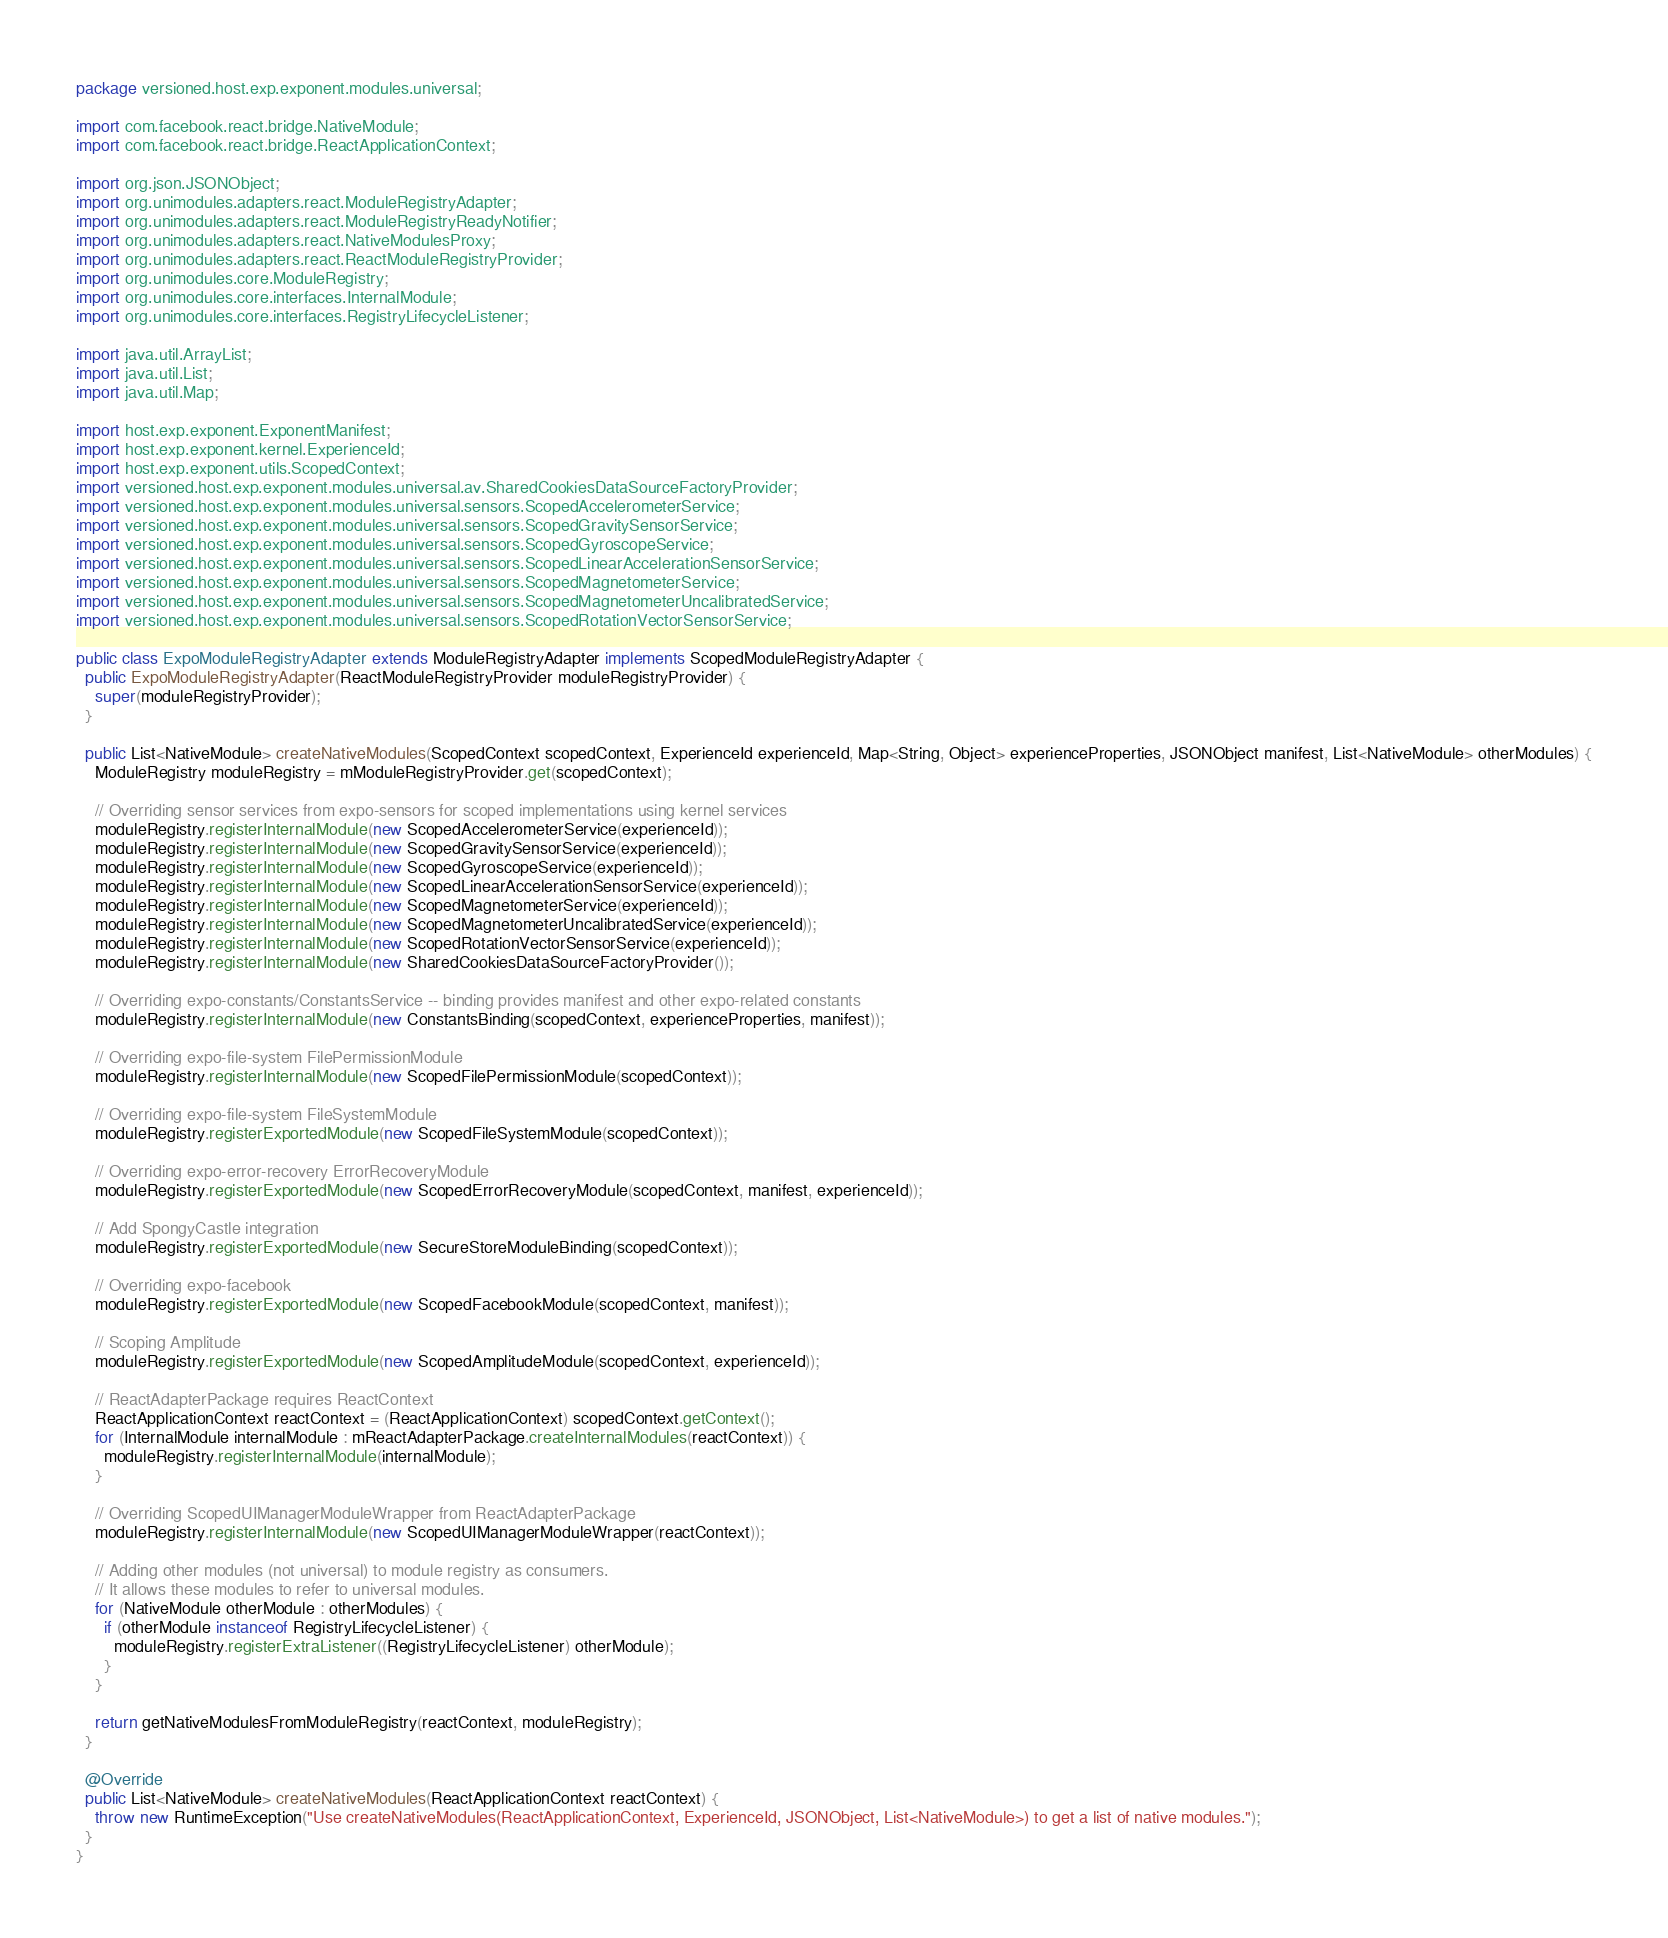<code> <loc_0><loc_0><loc_500><loc_500><_Java_>package versioned.host.exp.exponent.modules.universal;

import com.facebook.react.bridge.NativeModule;
import com.facebook.react.bridge.ReactApplicationContext;

import org.json.JSONObject;
import org.unimodules.adapters.react.ModuleRegistryAdapter;
import org.unimodules.adapters.react.ModuleRegistryReadyNotifier;
import org.unimodules.adapters.react.NativeModulesProxy;
import org.unimodules.adapters.react.ReactModuleRegistryProvider;
import org.unimodules.core.ModuleRegistry;
import org.unimodules.core.interfaces.InternalModule;
import org.unimodules.core.interfaces.RegistryLifecycleListener;

import java.util.ArrayList;
import java.util.List;
import java.util.Map;

import host.exp.exponent.ExponentManifest;
import host.exp.exponent.kernel.ExperienceId;
import host.exp.exponent.utils.ScopedContext;
import versioned.host.exp.exponent.modules.universal.av.SharedCookiesDataSourceFactoryProvider;
import versioned.host.exp.exponent.modules.universal.sensors.ScopedAccelerometerService;
import versioned.host.exp.exponent.modules.universal.sensors.ScopedGravitySensorService;
import versioned.host.exp.exponent.modules.universal.sensors.ScopedGyroscopeService;
import versioned.host.exp.exponent.modules.universal.sensors.ScopedLinearAccelerationSensorService;
import versioned.host.exp.exponent.modules.universal.sensors.ScopedMagnetometerService;
import versioned.host.exp.exponent.modules.universal.sensors.ScopedMagnetometerUncalibratedService;
import versioned.host.exp.exponent.modules.universal.sensors.ScopedRotationVectorSensorService;

public class ExpoModuleRegistryAdapter extends ModuleRegistryAdapter implements ScopedModuleRegistryAdapter {
  public ExpoModuleRegistryAdapter(ReactModuleRegistryProvider moduleRegistryProvider) {
    super(moduleRegistryProvider);
  }

  public List<NativeModule> createNativeModules(ScopedContext scopedContext, ExperienceId experienceId, Map<String, Object> experienceProperties, JSONObject manifest, List<NativeModule> otherModules) {
    ModuleRegistry moduleRegistry = mModuleRegistryProvider.get(scopedContext);

    // Overriding sensor services from expo-sensors for scoped implementations using kernel services
    moduleRegistry.registerInternalModule(new ScopedAccelerometerService(experienceId));
    moduleRegistry.registerInternalModule(new ScopedGravitySensorService(experienceId));
    moduleRegistry.registerInternalModule(new ScopedGyroscopeService(experienceId));
    moduleRegistry.registerInternalModule(new ScopedLinearAccelerationSensorService(experienceId));
    moduleRegistry.registerInternalModule(new ScopedMagnetometerService(experienceId));
    moduleRegistry.registerInternalModule(new ScopedMagnetometerUncalibratedService(experienceId));
    moduleRegistry.registerInternalModule(new ScopedRotationVectorSensorService(experienceId));
    moduleRegistry.registerInternalModule(new SharedCookiesDataSourceFactoryProvider());

    // Overriding expo-constants/ConstantsService -- binding provides manifest and other expo-related constants
    moduleRegistry.registerInternalModule(new ConstantsBinding(scopedContext, experienceProperties, manifest));

    // Overriding expo-file-system FilePermissionModule
    moduleRegistry.registerInternalModule(new ScopedFilePermissionModule(scopedContext));

    // Overriding expo-file-system FileSystemModule
    moduleRegistry.registerExportedModule(new ScopedFileSystemModule(scopedContext));

    // Overriding expo-error-recovery ErrorRecoveryModule
    moduleRegistry.registerExportedModule(new ScopedErrorRecoveryModule(scopedContext, manifest, experienceId));

    // Add SpongyCastle integration
    moduleRegistry.registerExportedModule(new SecureStoreModuleBinding(scopedContext));

    // Overriding expo-facebook
    moduleRegistry.registerExportedModule(new ScopedFacebookModule(scopedContext, manifest));

    // Scoping Amplitude
    moduleRegistry.registerExportedModule(new ScopedAmplitudeModule(scopedContext, experienceId));

    // ReactAdapterPackage requires ReactContext
    ReactApplicationContext reactContext = (ReactApplicationContext) scopedContext.getContext();
    for (InternalModule internalModule : mReactAdapterPackage.createInternalModules(reactContext)) {
      moduleRegistry.registerInternalModule(internalModule);
    }

    // Overriding ScopedUIManagerModuleWrapper from ReactAdapterPackage
    moduleRegistry.registerInternalModule(new ScopedUIManagerModuleWrapper(reactContext));

    // Adding other modules (not universal) to module registry as consumers.
    // It allows these modules to refer to universal modules.
    for (NativeModule otherModule : otherModules) {
      if (otherModule instanceof RegistryLifecycleListener) {
        moduleRegistry.registerExtraListener((RegistryLifecycleListener) otherModule);
      }
    }

    return getNativeModulesFromModuleRegistry(reactContext, moduleRegistry);
  }

  @Override
  public List<NativeModule> createNativeModules(ReactApplicationContext reactContext) {
    throw new RuntimeException("Use createNativeModules(ReactApplicationContext, ExperienceId, JSONObject, List<NativeModule>) to get a list of native modules.");
  }
}
</code> 